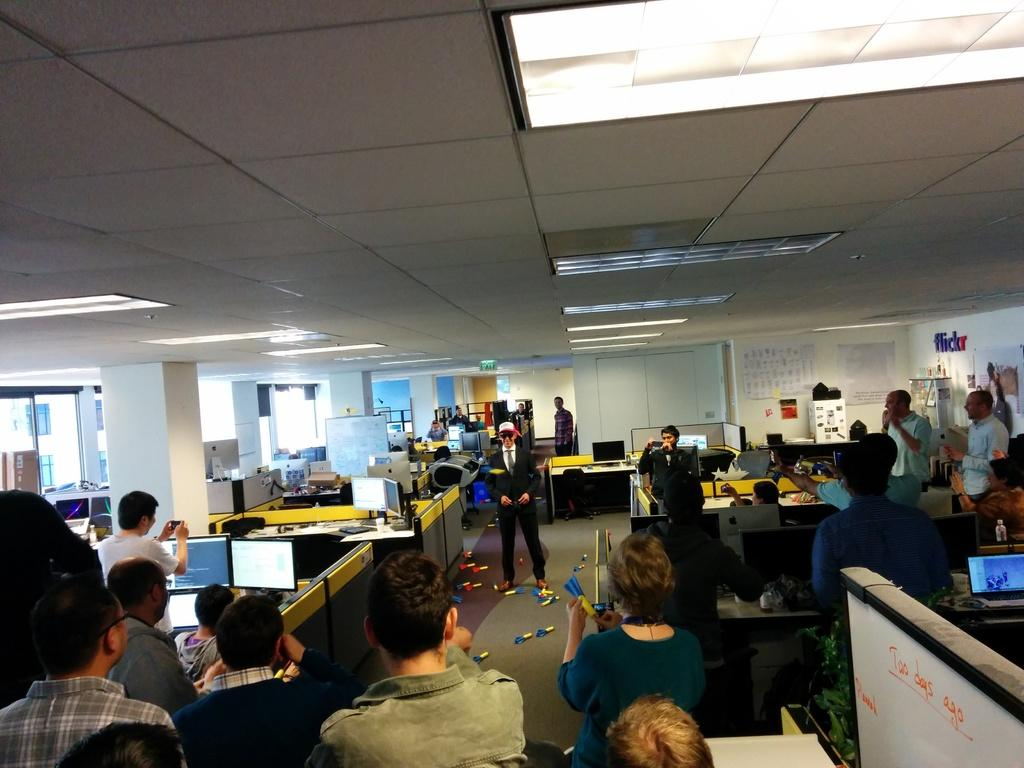How many people are in the image? There is a group of people in the image. What type of equipment is present in the image? There are monitors in the image. What type of furniture is present in the image? There are tables in the image. What type of architectural feature is present in the image? There are pillars in the image. What type of opening is present in the image? There are windows in the image. Can you describe the unspecified objects in objects in the image? Unfortunately, the provided facts do not specify the nature of the unspecified objects in the image. What type of van is parked outside the window in the image? There is no van present in the image; it only mentions windows and not any vehicles outside. Can you tell me how many aunts are in the group of people in the image? The provided facts do not specify the relationship of the people in the group, so we cannot determine how many aunts are present. 